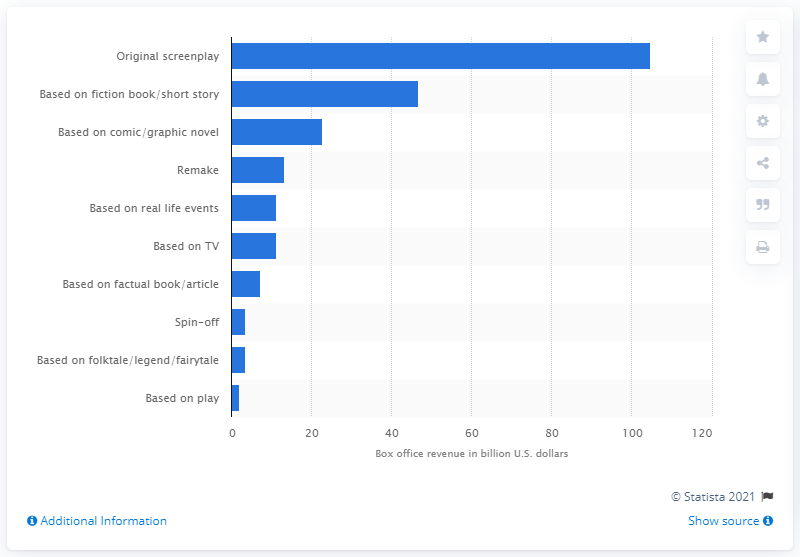Outline some significant characteristics in this image. Between 1995 and 2020, movies based on original screenplays earned a total of 104.87 billion dollars. 